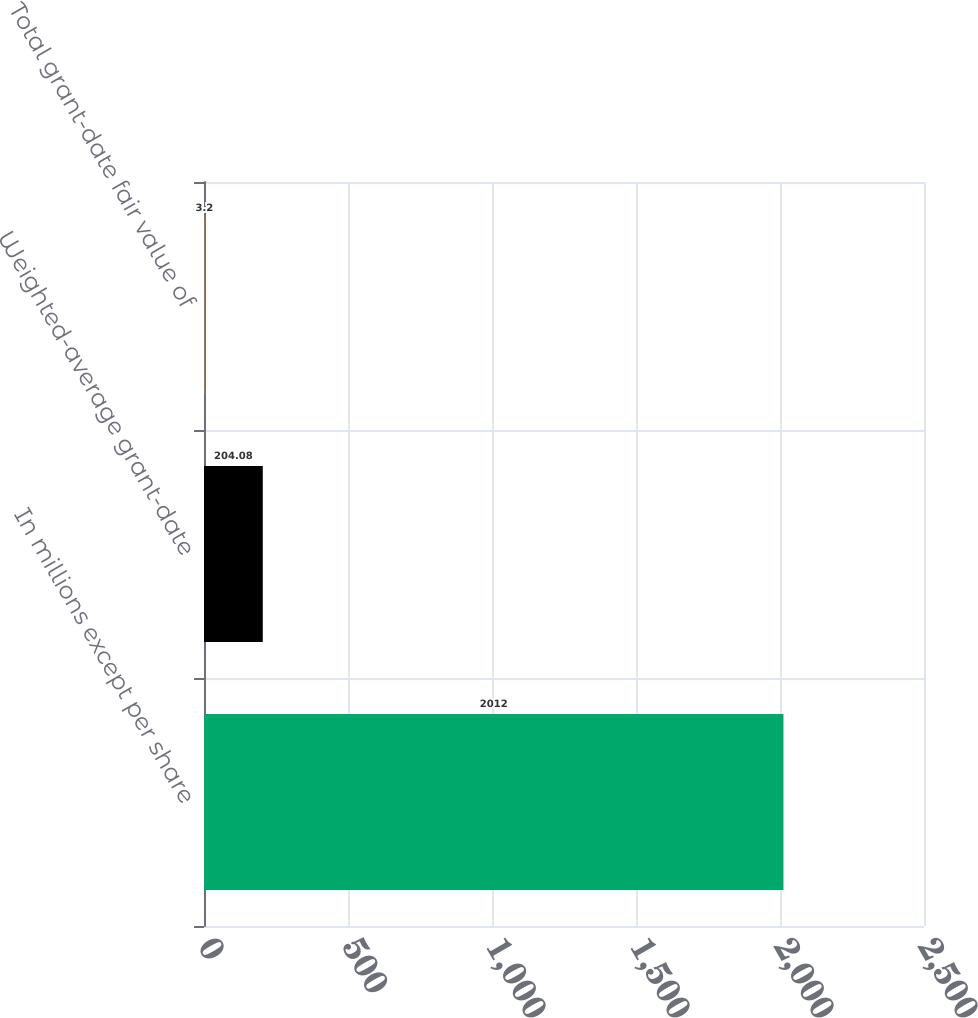Convert chart. <chart><loc_0><loc_0><loc_500><loc_500><bar_chart><fcel>In millions except per share<fcel>Weighted-average grant-date<fcel>Total grant-date fair value of<nl><fcel>2012<fcel>204.08<fcel>3.2<nl></chart> 